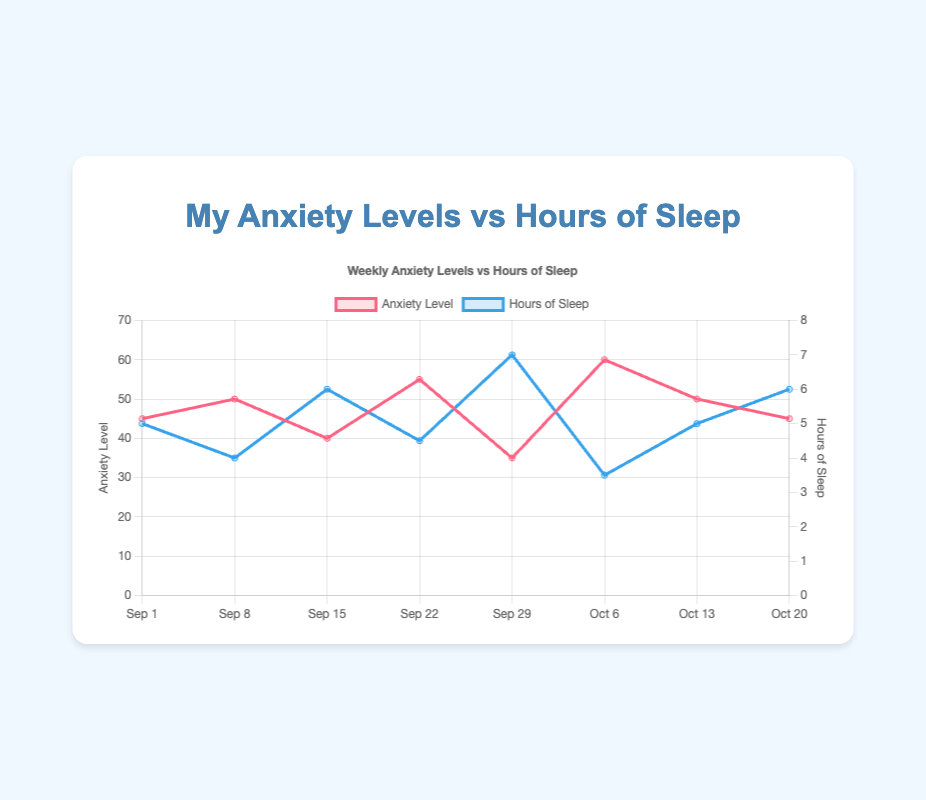What is the title of the chart? The title is displayed at the top of the chart, which reads "Weekly Anxiety Levels vs Hours of Sleep".
Answer: Weekly Anxiety Levels vs Hours of Sleep How many weeks of data are displayed in the chart? Each point along the x-axis represents a week, and there are 8 points from "Sep 1" to "Oct 20".
Answer: 8 Which week had the highest anxiety level? By scanning the "Anxiety Level" series, we see that the highest point is at "Oct 6" with an anxiety level of 60.
Answer: Oct 6 During which week did you get the most sleep? By observing the "Hours of Sleep" series, "Sep 29" stands out as the week with the most sleep at 7 hours.
Answer: Sep 29 Is there any week where the hours of sleep and anxiety levels are exactly equal? By comparing both datasets, there is no single week where the values for "Hours of Sleep" and "Anxiety Level" are equal.
Answer: No What is the difference in anxiety levels between the week of Sep 1 and Oct 6? The anxiety level on Sep 1 is 45 and on Oct 6 is 60. Subtracting these gives us 60 - 45 = 15.
Answer: 15 On which week did the anxiety level decrease the most compared to the previous week? Comparing consecutive weeks, Sep 15 shows the biggest drop from Sep 8, going from an anxiety level of 50 to 40, a decrease of 10.
Answer: Sep 15 What is the average hours of sleep over the 8 weeks? Sum the hours of sleep (5 + 4 + 6 + 4.5 + 7 + 3.5 + 5 + 6) = 41, then divide by the number of weeks (8). The average is 41/8 = 5.125 hours.
Answer: 5.125 hours How many weeks had an anxiety level above 50? By counting the number of weeks where anxiety level is above 50: Sep 22 (55), Oct 6 (60), and Oct 13 (50), but "50" itself is not above 50. Hence, only Sep 22 and Oct 6 qualify.
Answer: 2 weeks Is there a trend where lower hours of sleep correlate with higher anxiety levels? The data suggests a general trend; for example, Oct 6 (3.5 hours of sleep, 60 anxiety) and Sep 22 (4.5 hours of sleep, 55 anxiety) show higher anxiety levels with lower sleep.
Answer: Yes 